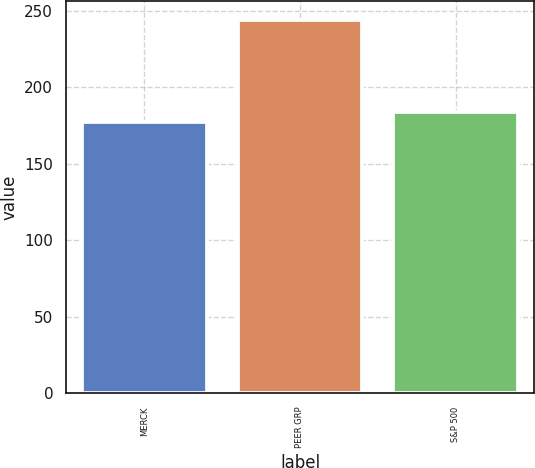Convert chart to OTSL. <chart><loc_0><loc_0><loc_500><loc_500><bar_chart><fcel>MERCK<fcel>PEER GRP<fcel>S&P 500<nl><fcel>177<fcel>244<fcel>183.7<nl></chart> 